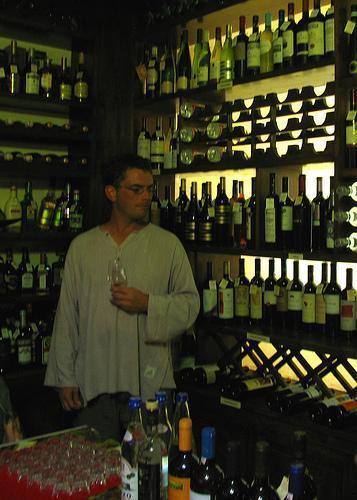How many bottles on the front table have orange tops?
Give a very brief answer. 1. 